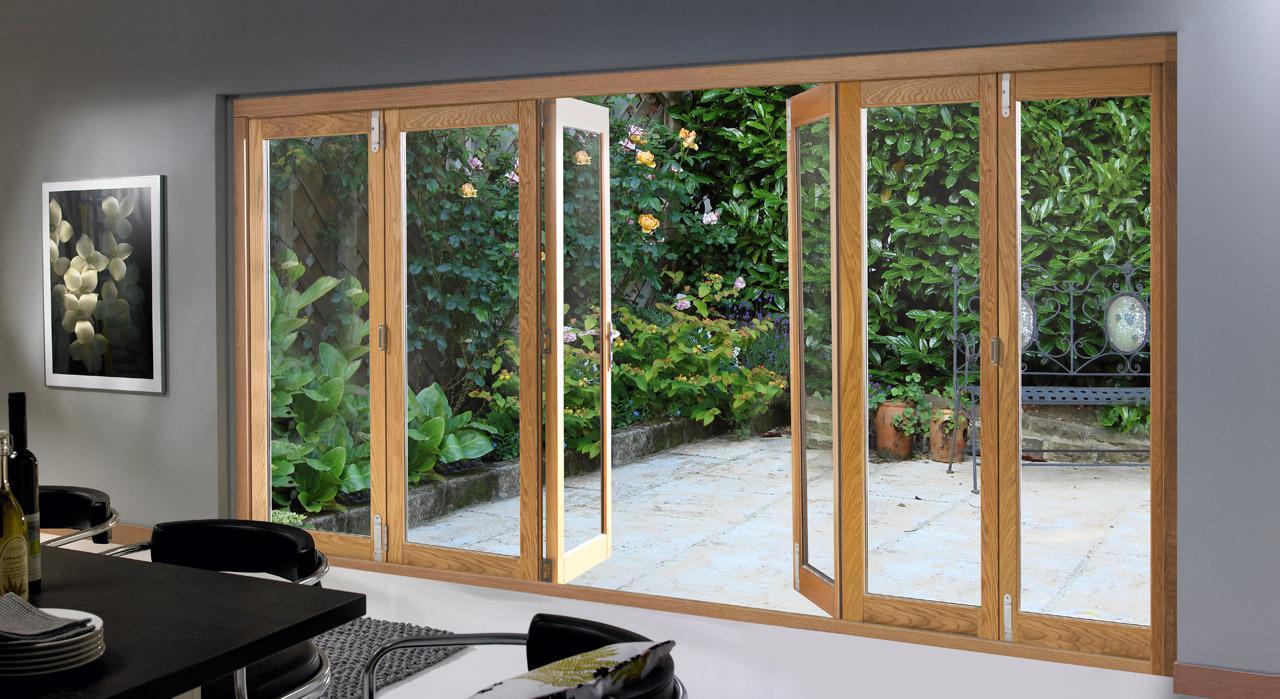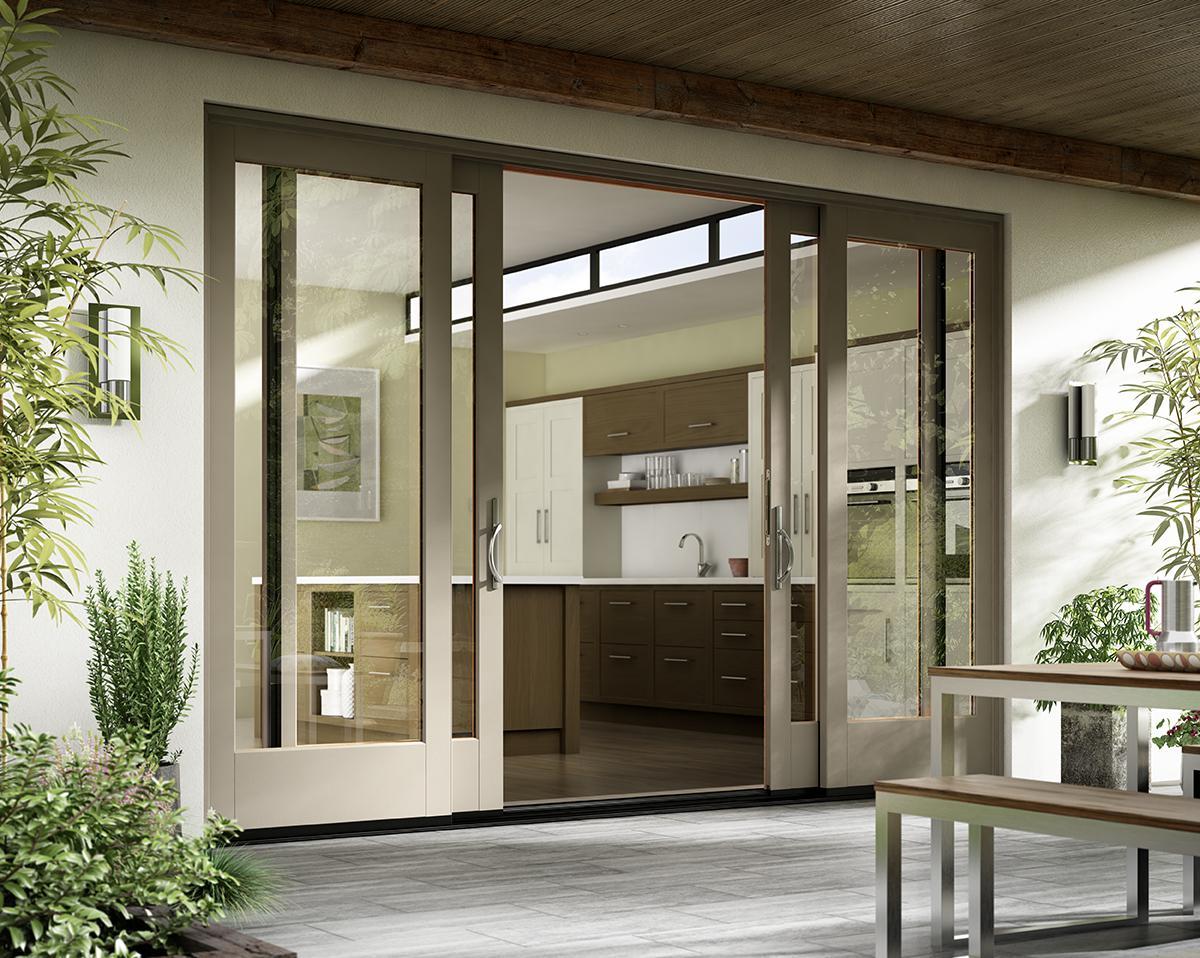The first image is the image on the left, the second image is the image on the right. Examine the images to the left and right. Is the description "There are two glass door with multiple panes that reveal grass and foliage in the backyard." accurate? Answer yes or no. No. The first image is the image on the left, the second image is the image on the right. Evaluate the accuracy of this statement regarding the images: "One image is looking in a wide open door from the outside.". Is it true? Answer yes or no. Yes. 